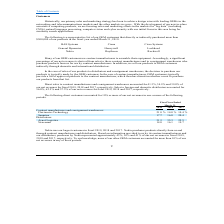According to Gsi Technology's financial document, Who was the largest customer in 2019, 2018 and 2017? According to the financial document, Nokia. The relevant text states: "Nokia Raytheon Rockwell Nokia Raytheon Rockwell Nokia Raytheon Rockwell..." Also, What was the percentage of purchases made by Nokia in 2019, 2018 and 2017 respectively? The document contains multiple relevant values: 45%, 36%, 41%. From the document: "es by Nokia represented approximately 45%, 36% and 41% of our net revenues in fiscal 2019, 2018 and 2017, respectively. To our knowledge, none of our ..." Also, What was the percentage from Flextronics Technology in 2019? According to the financial document, 21.8 (percentage). The relevant text states: "Flextronics Technology 21.8 % 14.0 % 10.4 %..." Additionally, In which year was Flextronics Technology less than 20.0%? The document shows two values: 2018 and 2017. Locate and analyze flextronics technology in row 5. From the document: "2019 2018 2017 2019 2018 2017..." Also, can you calculate: What was the change in net revenue from Sanmina from 2018 to 2019? Based on the calculation: 17.7 - 16.0, the result is 1.7 (percentage). This is based on the information: "Sanmina 17.7 16.0 20.4 Sanmina 17.7 16.0 20.4..." The key data points involved are: 16.0, 17.7. Also, can you calculate: What was the average revenues from Avnet Logistics between 2017-2019? To answer this question, I need to perform calculations using the financial data. The calculation is: (31.3 + 35.3 + 25.5) / 3, which equals 30.7 (percentage). This is based on the information: "Avnet Logistics 31.3 35.3 25.5 Avnet Logistics 31.3 35.3 25.5 Avnet Logistics 31.3 35.3 25.5..." The key data points involved are: 25.5, 31.3, 35.3. 